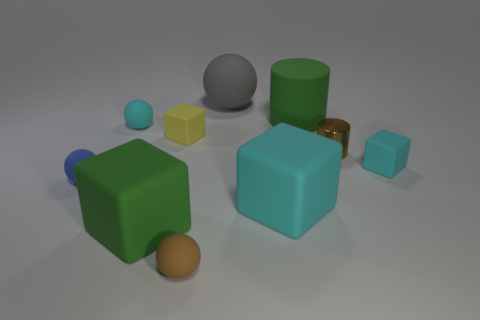Subtract all cubes. How many objects are left? 6 Add 5 cubes. How many cubes exist? 9 Subtract 0 green spheres. How many objects are left? 10 Subtract all yellow rubber cubes. Subtract all cylinders. How many objects are left? 7 Add 6 small cyan matte blocks. How many small cyan matte blocks are left? 7 